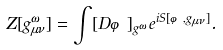<formula> <loc_0><loc_0><loc_500><loc_500>Z [ g _ { \mu \nu } ^ { \omega } ] = \int [ D \varphi ] _ { g ^ { \omega } } e ^ { i S [ \varphi , g _ { \mu \nu } ] } .</formula> 